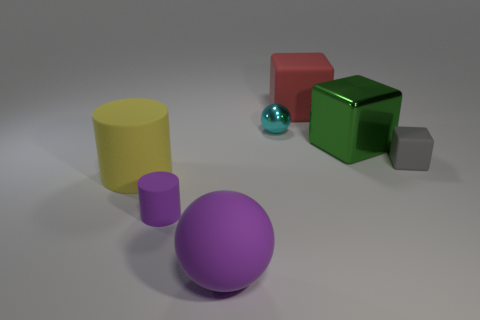Subtract all green balls. Subtract all blue cylinders. How many balls are left? 2 Add 1 green blocks. How many objects exist? 8 Subtract all cylinders. How many objects are left? 5 Add 6 gray rubber blocks. How many gray rubber blocks exist? 7 Subtract 0 brown spheres. How many objects are left? 7 Subtract all big purple rubber things. Subtract all green metallic objects. How many objects are left? 5 Add 1 small purple rubber things. How many small purple rubber things are left? 2 